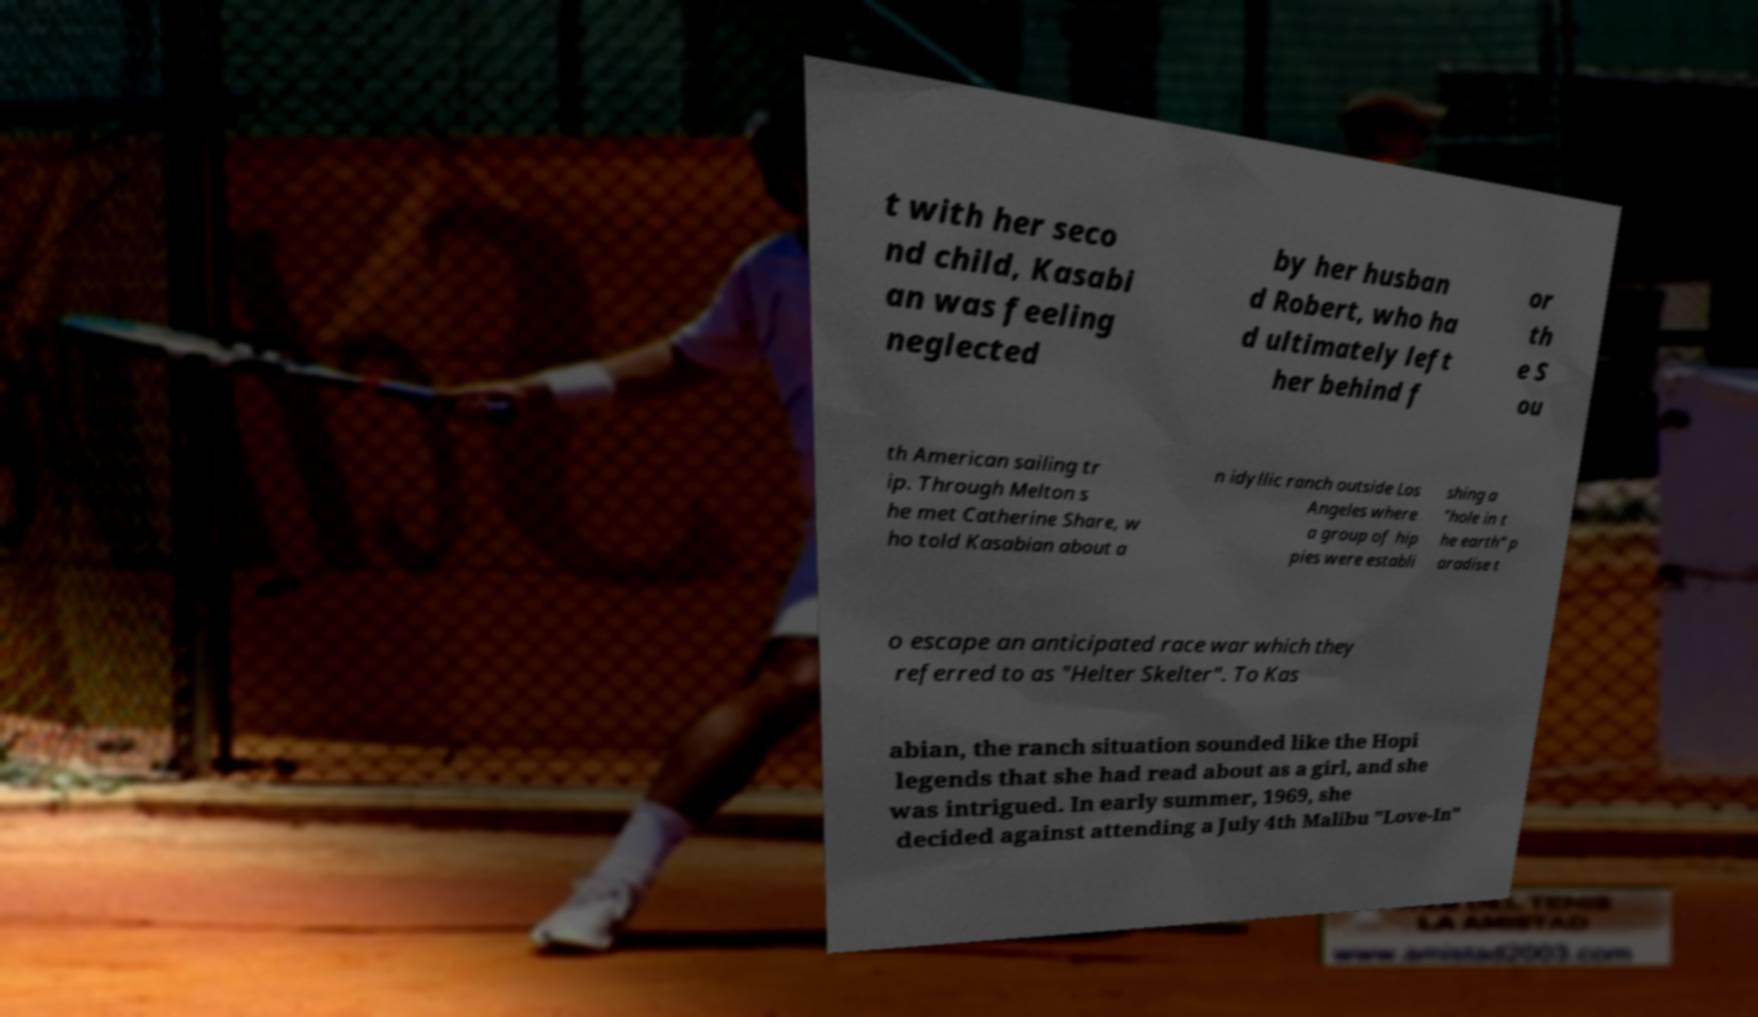Please read and relay the text visible in this image. What does it say? t with her seco nd child, Kasabi an was feeling neglected by her husban d Robert, who ha d ultimately left her behind f or th e S ou th American sailing tr ip. Through Melton s he met Catherine Share, w ho told Kasabian about a n idyllic ranch outside Los Angeles where a group of hip pies were establi shing a "hole in t he earth" p aradise t o escape an anticipated race war which they referred to as "Helter Skelter". To Kas abian, the ranch situation sounded like the Hopi legends that she had read about as a girl, and she was intrigued. In early summer, 1969, she decided against attending a July 4th Malibu "Love-In" 